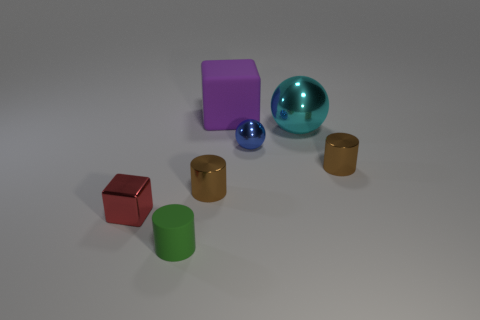Does the large purple rubber thing have the same shape as the large thing that is in front of the purple block?
Make the answer very short. No. Is the number of big cyan shiny spheres left of the cyan metal sphere the same as the number of blue things to the right of the purple matte block?
Provide a succinct answer. No. How many other things are made of the same material as the blue sphere?
Your response must be concise. 4. How many metallic objects are big red objects or blue objects?
Ensure brevity in your answer.  1. There is a tiny object in front of the small red shiny object; is it the same shape as the large purple thing?
Provide a succinct answer. No. Are there more brown objects that are in front of the small green cylinder than tiny green cylinders?
Offer a terse response. No. What number of objects are both in front of the tiny red cube and on the right side of the large purple rubber cube?
Keep it short and to the point. 0. What color is the matte object in front of the shiny thing on the left side of the tiny green cylinder?
Make the answer very short. Green. Are there fewer rubber cubes than cylinders?
Give a very brief answer. Yes. Are there more green cylinders that are in front of the shiny cube than small spheres that are on the right side of the cyan thing?
Your response must be concise. Yes. 